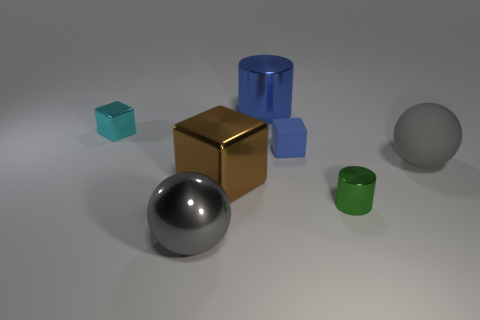Are there any big blue objects in front of the cyan metal object?
Ensure brevity in your answer.  No. There is another gray object that is the same shape as the gray matte thing; what is its size?
Keep it short and to the point. Large. Is there anything else that is the same size as the green cylinder?
Give a very brief answer. Yes. Do the blue metal thing and the green thing have the same shape?
Your answer should be very brief. Yes. What size is the metal thing that is in front of the tiny metallic thing that is to the right of the big gray metal sphere?
Offer a terse response. Large. What color is the other metallic thing that is the same shape as the small green object?
Ensure brevity in your answer.  Blue. How many cylinders are the same color as the large matte sphere?
Keep it short and to the point. 0. What size is the green metal cylinder?
Give a very brief answer. Small. Does the green metallic thing have the same size as the blue cube?
Provide a succinct answer. Yes. There is a block that is both behind the gray rubber ball and left of the small blue thing; what is its color?
Keep it short and to the point. Cyan. 